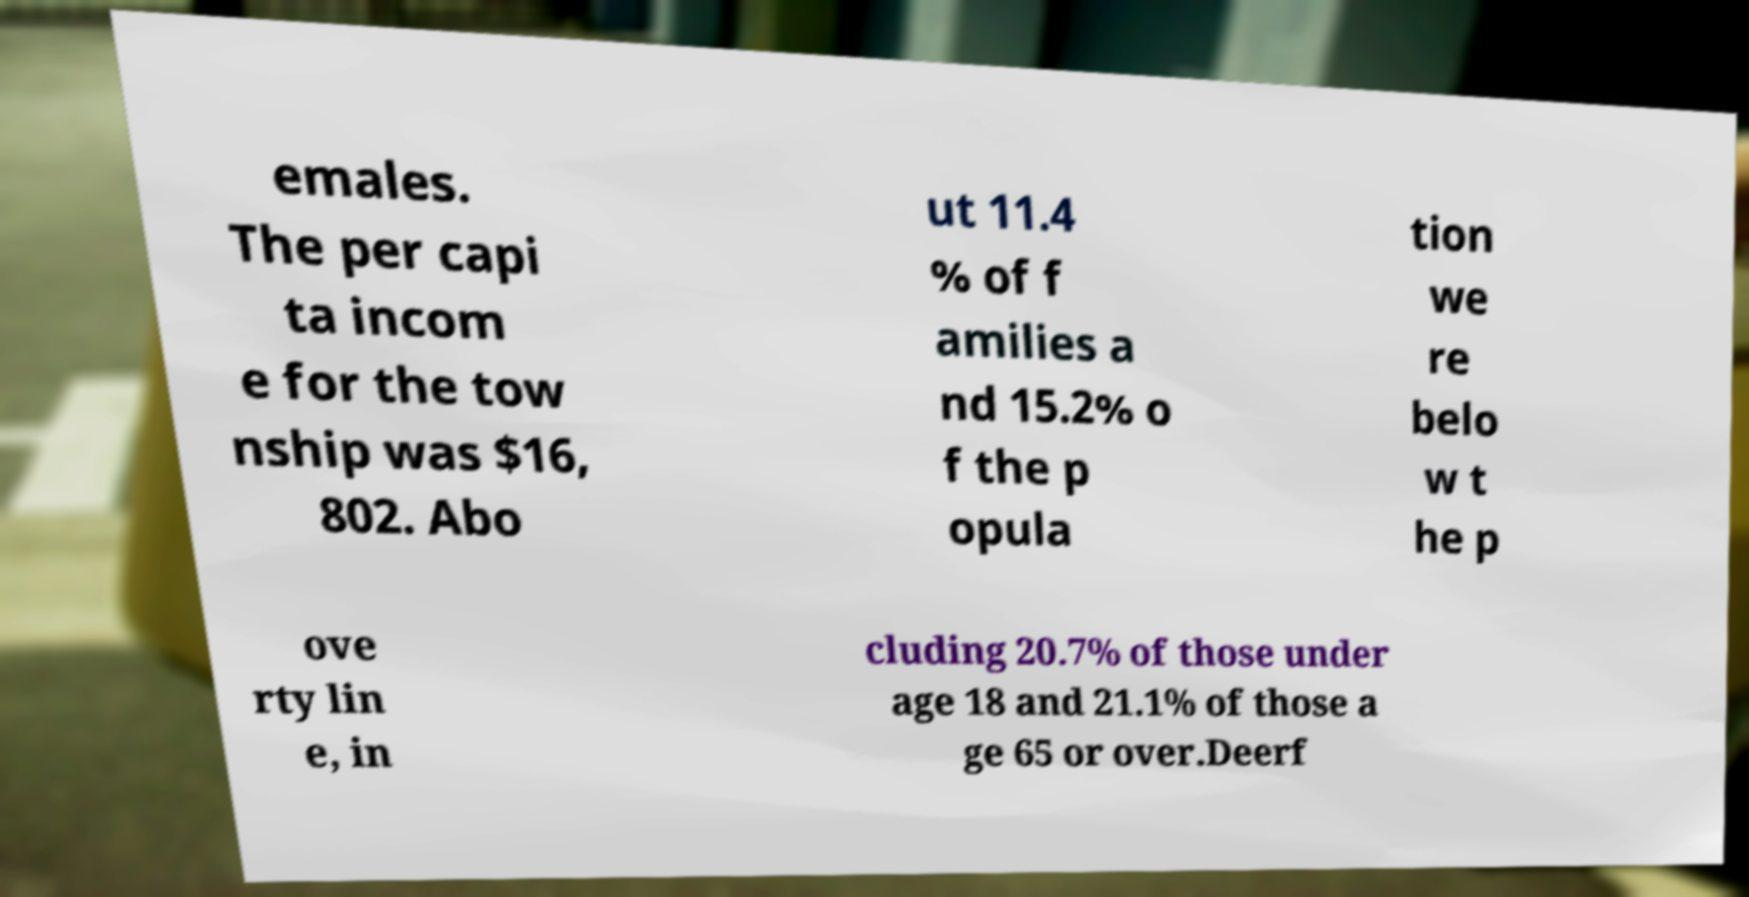What messages or text are displayed in this image? I need them in a readable, typed format. emales. The per capi ta incom e for the tow nship was $16, 802. Abo ut 11.4 % of f amilies a nd 15.2% o f the p opula tion we re belo w t he p ove rty lin e, in cluding 20.7% of those under age 18 and 21.1% of those a ge 65 or over.Deerf 